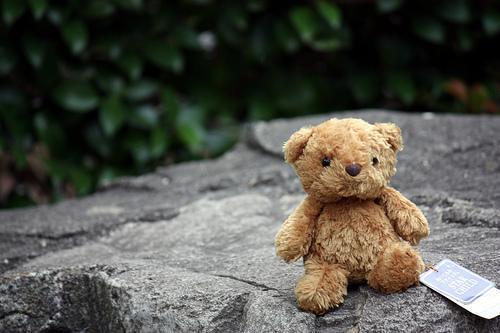How many teddy bears?
Give a very brief answer. 1. How many ears?
Give a very brief answer. 2. 